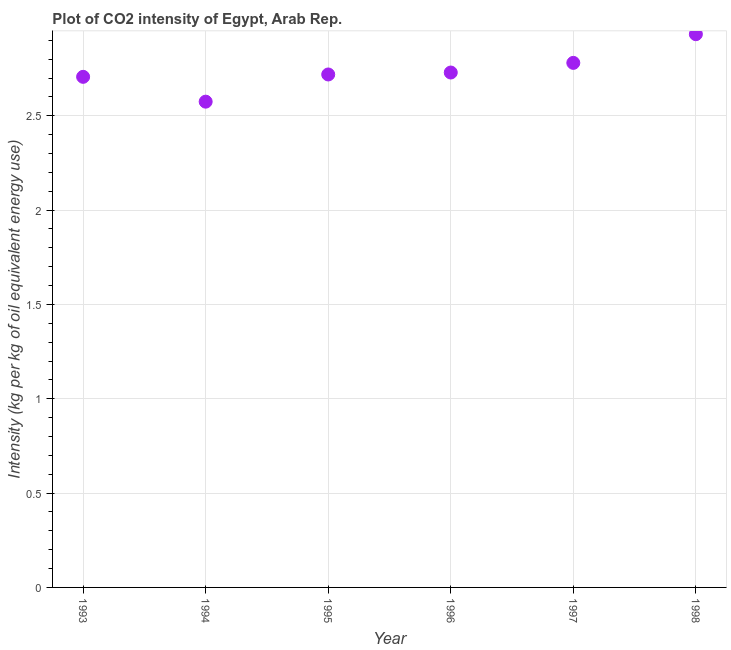What is the co2 intensity in 1997?
Ensure brevity in your answer.  2.78. Across all years, what is the maximum co2 intensity?
Make the answer very short. 2.93. Across all years, what is the minimum co2 intensity?
Offer a terse response. 2.57. In which year was the co2 intensity minimum?
Your answer should be very brief. 1994. What is the sum of the co2 intensity?
Your answer should be compact. 16.44. What is the difference between the co2 intensity in 1995 and 1998?
Make the answer very short. -0.21. What is the average co2 intensity per year?
Make the answer very short. 2.74. What is the median co2 intensity?
Make the answer very short. 2.72. Do a majority of the years between 1993 and 1996 (inclusive) have co2 intensity greater than 1.9 kg?
Give a very brief answer. Yes. What is the ratio of the co2 intensity in 1994 to that in 1995?
Provide a succinct answer. 0.95. What is the difference between the highest and the second highest co2 intensity?
Your answer should be compact. 0.15. Is the sum of the co2 intensity in 1993 and 1995 greater than the maximum co2 intensity across all years?
Your answer should be very brief. Yes. What is the difference between the highest and the lowest co2 intensity?
Provide a short and direct response. 0.36. How many years are there in the graph?
Ensure brevity in your answer.  6. Does the graph contain any zero values?
Provide a short and direct response. No. Does the graph contain grids?
Make the answer very short. Yes. What is the title of the graph?
Offer a terse response. Plot of CO2 intensity of Egypt, Arab Rep. What is the label or title of the X-axis?
Your response must be concise. Year. What is the label or title of the Y-axis?
Keep it short and to the point. Intensity (kg per kg of oil equivalent energy use). What is the Intensity (kg per kg of oil equivalent energy use) in 1993?
Offer a very short reply. 2.71. What is the Intensity (kg per kg of oil equivalent energy use) in 1994?
Your answer should be very brief. 2.57. What is the Intensity (kg per kg of oil equivalent energy use) in 1995?
Provide a succinct answer. 2.72. What is the Intensity (kg per kg of oil equivalent energy use) in 1996?
Your response must be concise. 2.73. What is the Intensity (kg per kg of oil equivalent energy use) in 1997?
Offer a very short reply. 2.78. What is the Intensity (kg per kg of oil equivalent energy use) in 1998?
Keep it short and to the point. 2.93. What is the difference between the Intensity (kg per kg of oil equivalent energy use) in 1993 and 1994?
Offer a terse response. 0.13. What is the difference between the Intensity (kg per kg of oil equivalent energy use) in 1993 and 1995?
Your answer should be compact. -0.01. What is the difference between the Intensity (kg per kg of oil equivalent energy use) in 1993 and 1996?
Provide a succinct answer. -0.02. What is the difference between the Intensity (kg per kg of oil equivalent energy use) in 1993 and 1997?
Provide a succinct answer. -0.07. What is the difference between the Intensity (kg per kg of oil equivalent energy use) in 1993 and 1998?
Ensure brevity in your answer.  -0.23. What is the difference between the Intensity (kg per kg of oil equivalent energy use) in 1994 and 1995?
Your answer should be compact. -0.14. What is the difference between the Intensity (kg per kg of oil equivalent energy use) in 1994 and 1996?
Offer a terse response. -0.15. What is the difference between the Intensity (kg per kg of oil equivalent energy use) in 1994 and 1997?
Provide a succinct answer. -0.21. What is the difference between the Intensity (kg per kg of oil equivalent energy use) in 1994 and 1998?
Make the answer very short. -0.36. What is the difference between the Intensity (kg per kg of oil equivalent energy use) in 1995 and 1996?
Ensure brevity in your answer.  -0.01. What is the difference between the Intensity (kg per kg of oil equivalent energy use) in 1995 and 1997?
Your response must be concise. -0.06. What is the difference between the Intensity (kg per kg of oil equivalent energy use) in 1995 and 1998?
Provide a short and direct response. -0.21. What is the difference between the Intensity (kg per kg of oil equivalent energy use) in 1996 and 1997?
Offer a terse response. -0.05. What is the difference between the Intensity (kg per kg of oil equivalent energy use) in 1996 and 1998?
Make the answer very short. -0.2. What is the difference between the Intensity (kg per kg of oil equivalent energy use) in 1997 and 1998?
Provide a short and direct response. -0.15. What is the ratio of the Intensity (kg per kg of oil equivalent energy use) in 1993 to that in 1994?
Offer a terse response. 1.05. What is the ratio of the Intensity (kg per kg of oil equivalent energy use) in 1993 to that in 1995?
Your answer should be compact. 0.99. What is the ratio of the Intensity (kg per kg of oil equivalent energy use) in 1993 to that in 1998?
Offer a very short reply. 0.92. What is the ratio of the Intensity (kg per kg of oil equivalent energy use) in 1994 to that in 1995?
Your response must be concise. 0.95. What is the ratio of the Intensity (kg per kg of oil equivalent energy use) in 1994 to that in 1996?
Your response must be concise. 0.94. What is the ratio of the Intensity (kg per kg of oil equivalent energy use) in 1994 to that in 1997?
Ensure brevity in your answer.  0.93. What is the ratio of the Intensity (kg per kg of oil equivalent energy use) in 1994 to that in 1998?
Provide a short and direct response. 0.88. What is the ratio of the Intensity (kg per kg of oil equivalent energy use) in 1995 to that in 1996?
Keep it short and to the point. 1. What is the ratio of the Intensity (kg per kg of oil equivalent energy use) in 1995 to that in 1998?
Give a very brief answer. 0.93. What is the ratio of the Intensity (kg per kg of oil equivalent energy use) in 1996 to that in 1998?
Provide a succinct answer. 0.93. What is the ratio of the Intensity (kg per kg of oil equivalent energy use) in 1997 to that in 1998?
Provide a short and direct response. 0.95. 